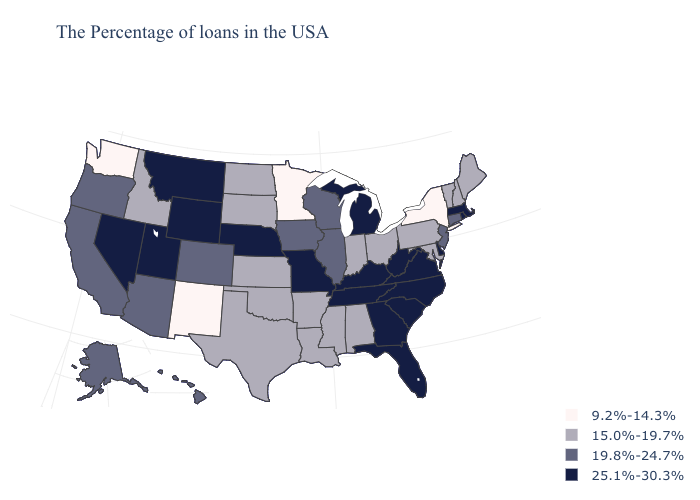Among the states that border Illinois , does Indiana have the lowest value?
Write a very short answer. Yes. Name the states that have a value in the range 19.8%-24.7%?
Be succinct. Connecticut, New Jersey, Wisconsin, Illinois, Iowa, Colorado, Arizona, California, Oregon, Alaska, Hawaii. What is the lowest value in states that border Missouri?
Concise answer only. 15.0%-19.7%. Name the states that have a value in the range 15.0%-19.7%?
Concise answer only. Maine, New Hampshire, Vermont, Maryland, Pennsylvania, Ohio, Indiana, Alabama, Mississippi, Louisiana, Arkansas, Kansas, Oklahoma, Texas, South Dakota, North Dakota, Idaho. Which states have the lowest value in the USA?
Write a very short answer. New York, Minnesota, New Mexico, Washington. What is the value of Arizona?
Give a very brief answer. 19.8%-24.7%. Does the first symbol in the legend represent the smallest category?
Keep it brief. Yes. Among the states that border Arizona , which have the lowest value?
Keep it brief. New Mexico. Name the states that have a value in the range 15.0%-19.7%?
Answer briefly. Maine, New Hampshire, Vermont, Maryland, Pennsylvania, Ohio, Indiana, Alabama, Mississippi, Louisiana, Arkansas, Kansas, Oklahoma, Texas, South Dakota, North Dakota, Idaho. Name the states that have a value in the range 19.8%-24.7%?
Be succinct. Connecticut, New Jersey, Wisconsin, Illinois, Iowa, Colorado, Arizona, California, Oregon, Alaska, Hawaii. Which states have the lowest value in the MidWest?
Keep it brief. Minnesota. What is the value of Utah?
Write a very short answer. 25.1%-30.3%. Does New Jersey have the highest value in the USA?
Write a very short answer. No. What is the lowest value in states that border Illinois?
Short answer required. 15.0%-19.7%. Name the states that have a value in the range 15.0%-19.7%?
Quick response, please. Maine, New Hampshire, Vermont, Maryland, Pennsylvania, Ohio, Indiana, Alabama, Mississippi, Louisiana, Arkansas, Kansas, Oklahoma, Texas, South Dakota, North Dakota, Idaho. 